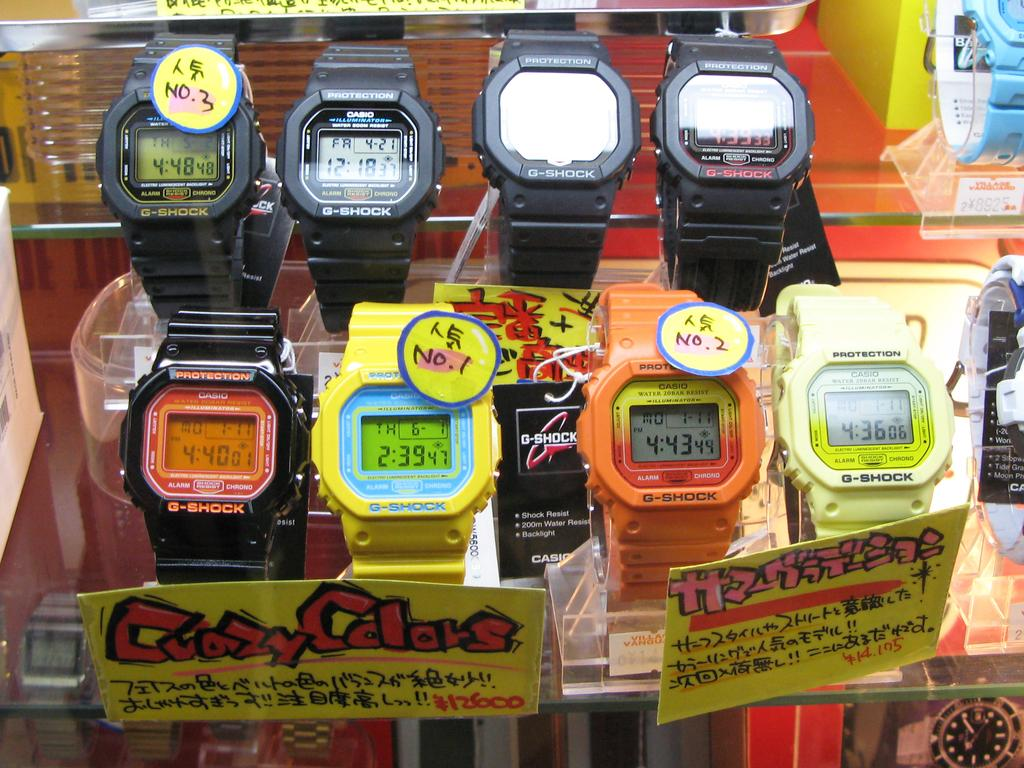<image>
Create a compact narrative representing the image presented. the time on a watch that says 2:39 on it 